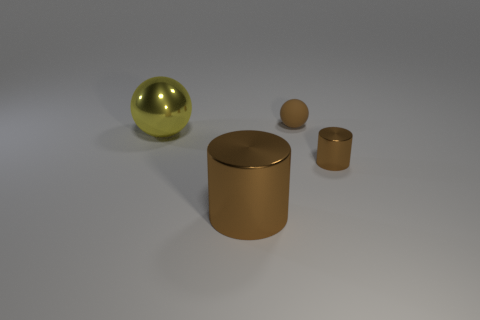Add 2 small blue cylinders. How many objects exist? 6 Subtract all yellow metallic objects. Subtract all brown matte balls. How many objects are left? 2 Add 2 tiny brown balls. How many tiny brown balls are left? 3 Add 3 matte things. How many matte things exist? 4 Subtract 0 cyan blocks. How many objects are left? 4 